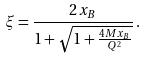Convert formula to latex. <formula><loc_0><loc_0><loc_500><loc_500>\xi = \frac { 2 x _ { B } } { 1 + \sqrt { 1 + \frac { 4 M x _ { B } } { Q ^ { 2 } } } } \, .</formula> 